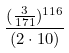<formula> <loc_0><loc_0><loc_500><loc_500>\frac { ( \frac { 3 } { 1 7 1 } ) ^ { 1 1 6 } } { ( 2 \cdot 1 0 ) }</formula> 